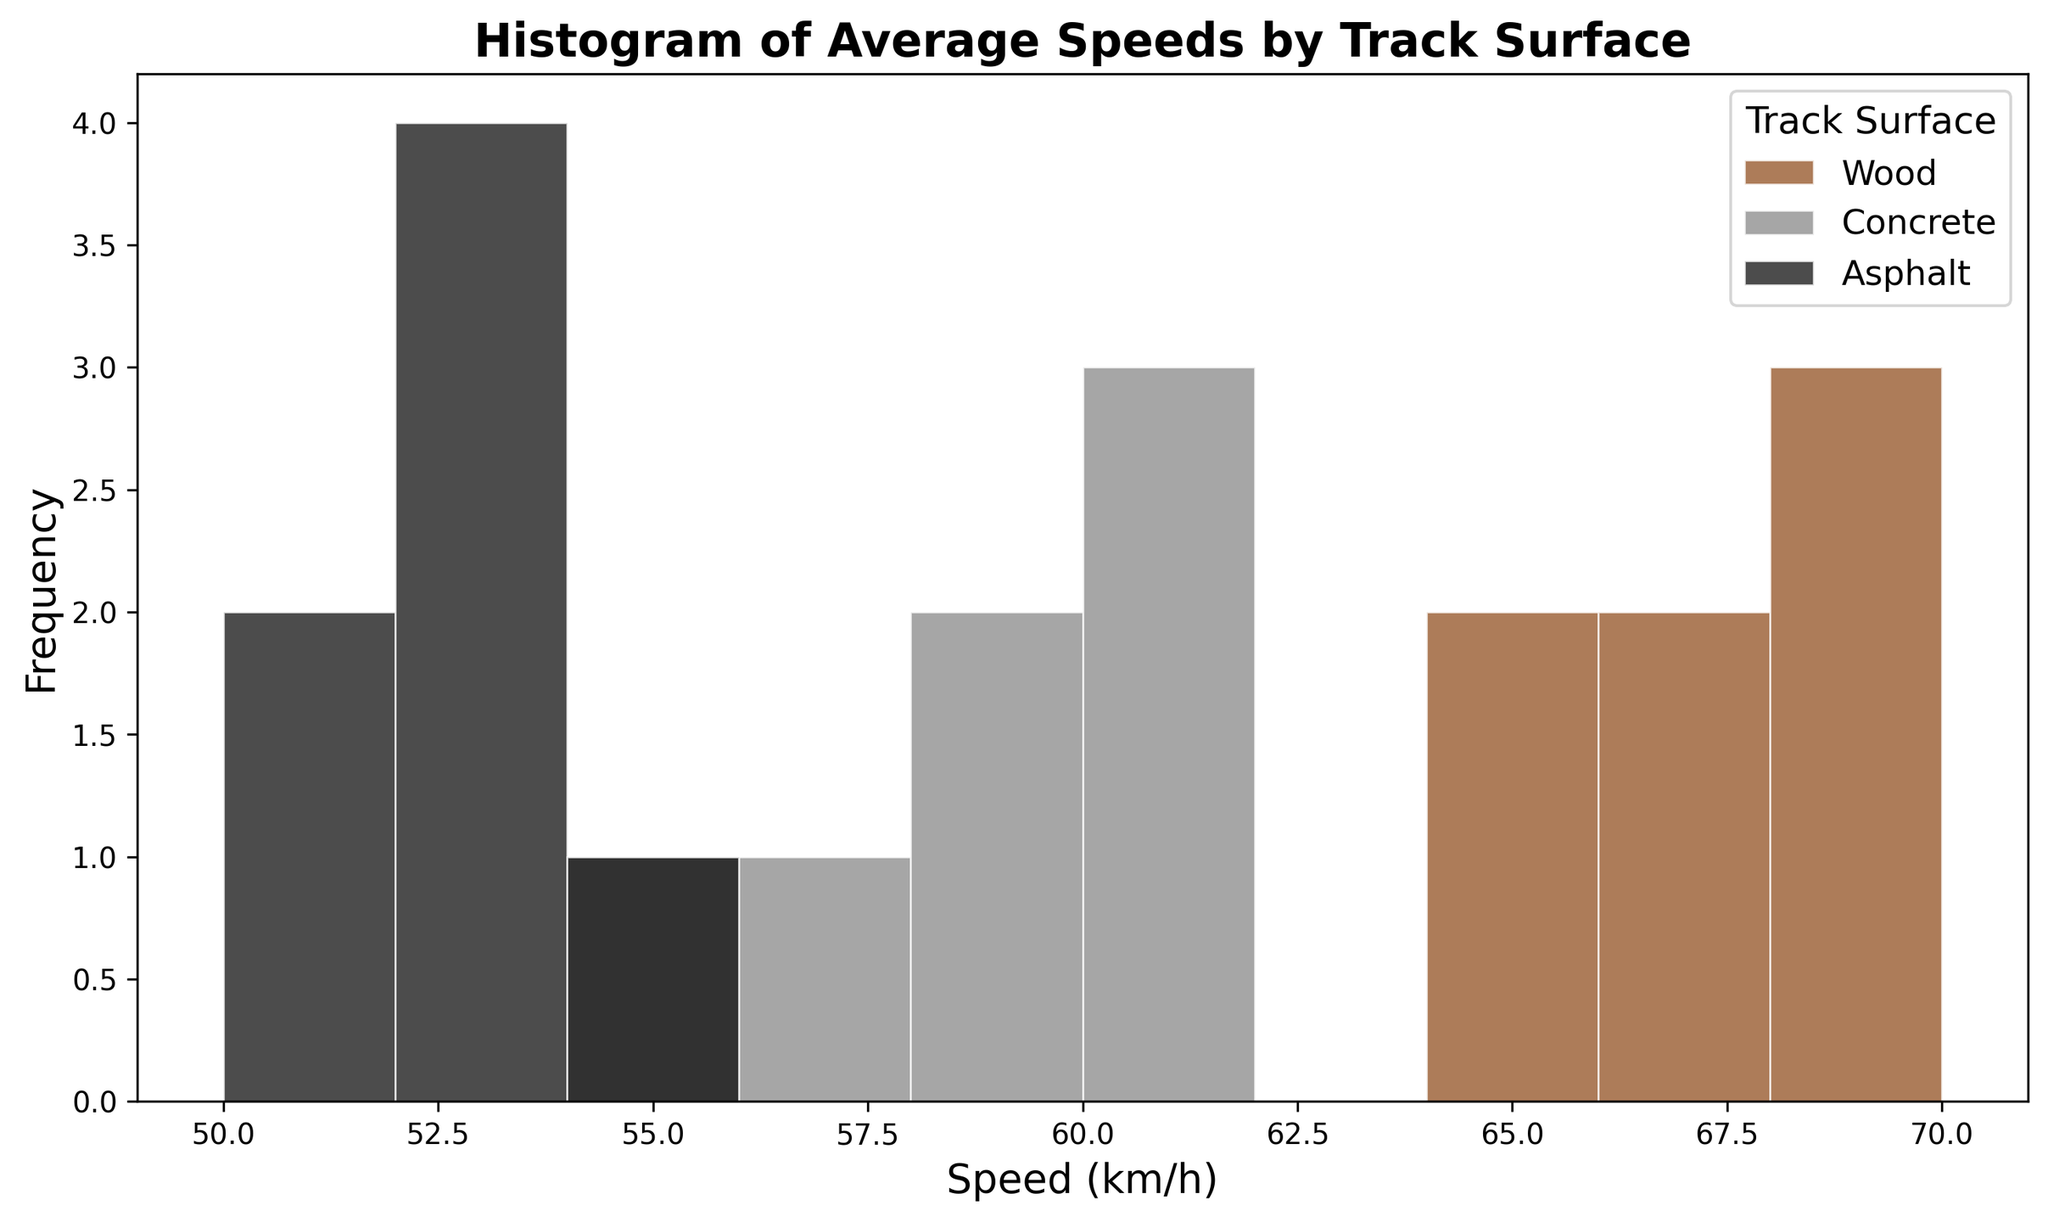What track surface has the highest average speed? To determine which track surface has the highest average speed, we compare the histogram bars' frequency relating to the central tendency. The Wood track exhibits higher speeds (65-70 km/h) compared to Concrete and Asphalt.
Answer: Wood Which track surface has the lowest average speed? By observing the histogram, the bars for Asphalt track show consistently lower speeds (50-54 km/h) relative to Wood and Concrete tracks.
Answer: Asphalt How many different speed ranges are displayed for the Concrete track surface? Examine the Concrete histogram bars and count distinct speed ranges presented. Concrete shows frequency bars within the 55-61 km/h range.
Answer: 4 In which speed range does the Wood track surface have the highest frequency? To find the speed range with the highest frequency for Wood, observe the height of the bars in the Wood histogram. The highest is within the 68-70 km/h range.
Answer: 68-70 km/h Which speed range has the highest overlap (containing bars from all three track surfaces)? Identify the speed range where all three colored bars are present. The overlapping histograms for Wood, Concrete, and Asphalt indicate the 52-54 km/h range as common to all.
Answer: 52-54 km/h What is the frequency of speeds between 60-62 km/h for the Concrete surface? Check the Concrete histogram within the 60-62 km/h range and note the bar height representing counts.
Answer: 1 Compare the distributions of Asphalt and Concrete: which has greater variability in speed? Evaluate the spread of histogram bars for Asphalt (50-54 km/h) compared to Concrete (55-61 km/h). Concrete’s speeds span a wider range indicating greater variability.
Answer: Concrete Which surface has the minimum speed recorded and what is its value? By examining the lowest end of the histograms for all surfaces, Asphalt’s histogram starts at 50 km/h, the smallest speed value.
Answer: Asphalt, 50 km/h Calculate the total frequency of speeds on the Wood track surface. Sum the frequencies from the Wood histogram bars (4 bins: 65-66, 67-68, 69-70).
Answer: 7 For the Wood track, what is the range between the minimum and maximum speed observed? Identify the minimum (64 km/h) and maximum (70 km/h) speeds in the Wood histogram and compute their difference: 70 - 64 = 6 km/h.
Answer: 6 km/h 